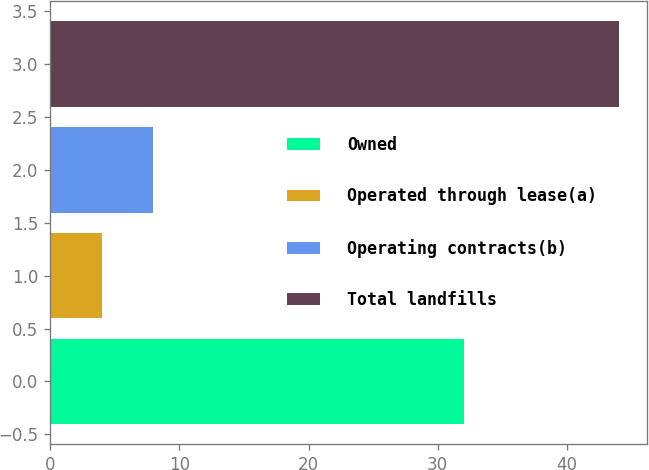Convert chart. <chart><loc_0><loc_0><loc_500><loc_500><bar_chart><fcel>Owned<fcel>Operated through lease(a)<fcel>Operating contracts(b)<fcel>Total landfills<nl><fcel>32<fcel>4<fcel>8<fcel>44<nl></chart> 